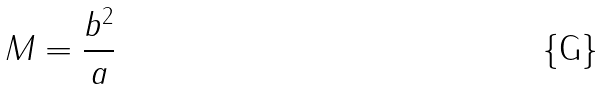Convert formula to latex. <formula><loc_0><loc_0><loc_500><loc_500>M = \frac { b ^ { 2 } } { a }</formula> 